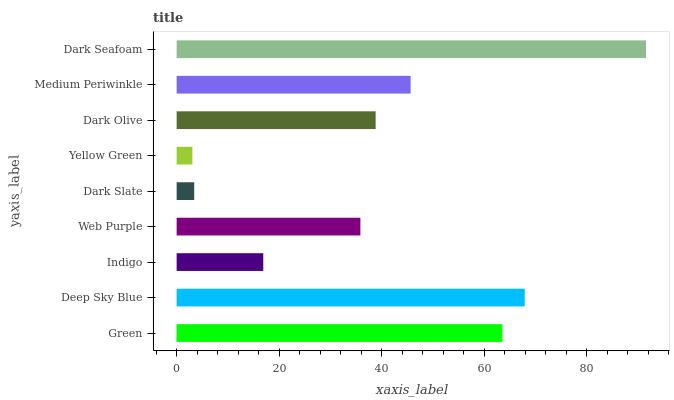Is Yellow Green the minimum?
Answer yes or no. Yes. Is Dark Seafoam the maximum?
Answer yes or no. Yes. Is Deep Sky Blue the minimum?
Answer yes or no. No. Is Deep Sky Blue the maximum?
Answer yes or no. No. Is Deep Sky Blue greater than Green?
Answer yes or no. Yes. Is Green less than Deep Sky Blue?
Answer yes or no. Yes. Is Green greater than Deep Sky Blue?
Answer yes or no. No. Is Deep Sky Blue less than Green?
Answer yes or no. No. Is Dark Olive the high median?
Answer yes or no. Yes. Is Dark Olive the low median?
Answer yes or no. Yes. Is Green the high median?
Answer yes or no. No. Is Dark Slate the low median?
Answer yes or no. No. 